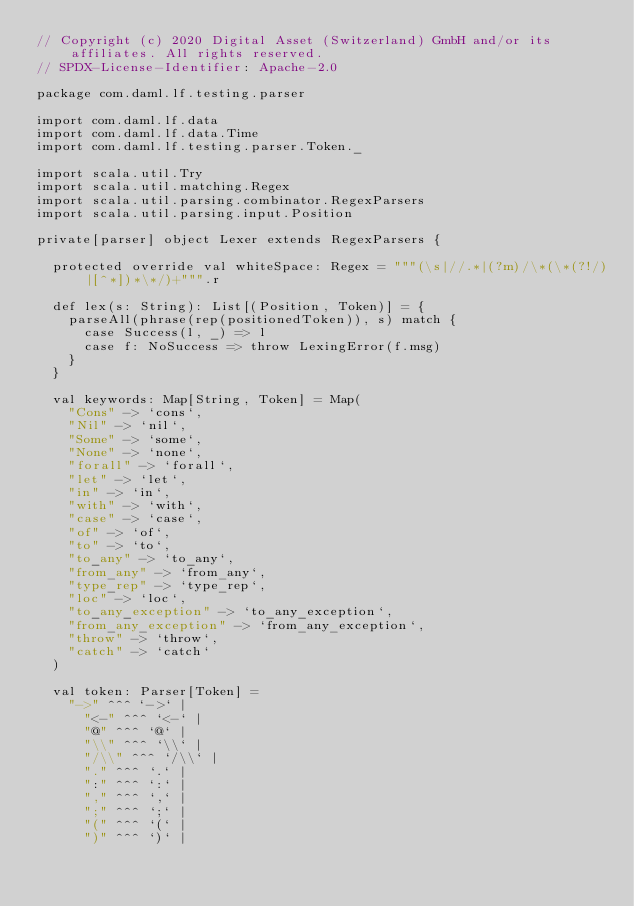Convert code to text. <code><loc_0><loc_0><loc_500><loc_500><_Scala_>// Copyright (c) 2020 Digital Asset (Switzerland) GmbH and/or its affiliates. All rights reserved.
// SPDX-License-Identifier: Apache-2.0

package com.daml.lf.testing.parser

import com.daml.lf.data
import com.daml.lf.data.Time
import com.daml.lf.testing.parser.Token._

import scala.util.Try
import scala.util.matching.Regex
import scala.util.parsing.combinator.RegexParsers
import scala.util.parsing.input.Position

private[parser] object Lexer extends RegexParsers {

  protected override val whiteSpace: Regex = """(\s|//.*|(?m)/\*(\*(?!/)|[^*])*\*/)+""".r

  def lex(s: String): List[(Position, Token)] = {
    parseAll(phrase(rep(positionedToken)), s) match {
      case Success(l, _) => l
      case f: NoSuccess => throw LexingError(f.msg)
    }
  }

  val keywords: Map[String, Token] = Map(
    "Cons" -> `cons`,
    "Nil" -> `nil`,
    "Some" -> `some`,
    "None" -> `none`,
    "forall" -> `forall`,
    "let" -> `let`,
    "in" -> `in`,
    "with" -> `with`,
    "case" -> `case`,
    "of" -> `of`,
    "to" -> `to`,
    "to_any" -> `to_any`,
    "from_any" -> `from_any`,
    "type_rep" -> `type_rep`,
    "loc" -> `loc`,
    "to_any_exception" -> `to_any_exception`,
    "from_any_exception" -> `from_any_exception`,
    "throw" -> `throw`,
    "catch" -> `catch`
  )

  val token: Parser[Token] =
    "->" ^^^ `->` |
      "<-" ^^^ `<-` |
      "@" ^^^ `@` |
      "\\" ^^^ `\\` |
      "/\\" ^^^ `/\\` |
      "." ^^^ `.` |
      ":" ^^^ `:` |
      "," ^^^ `,` |
      ";" ^^^ `;` |
      "(" ^^^ `(` |
      ")" ^^^ `)` |</code> 